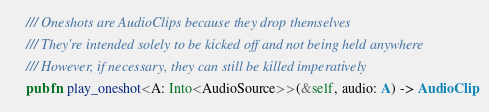Convert code to text. <code><loc_0><loc_0><loc_500><loc_500><_Rust_>
    /// Oneshots are AudioClips because they drop themselves
    /// They're intended solely to be kicked off and not being held anywhere
    /// However, if necessary, they can still be killed imperatively
    pub fn play_oneshot<A: Into<AudioSource>>(&self, audio: A) -> AudioClip</code> 